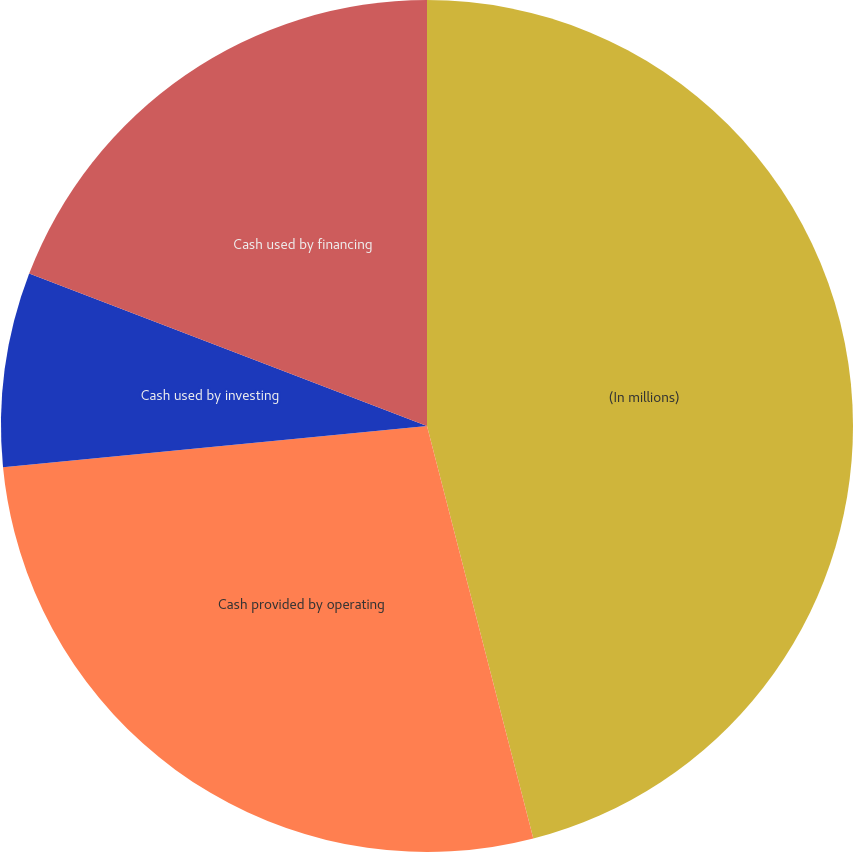Convert chart to OTSL. <chart><loc_0><loc_0><loc_500><loc_500><pie_chart><fcel>(In millions)<fcel>Cash provided by operating<fcel>Cash used by investing<fcel>Cash used by financing<nl><fcel>45.99%<fcel>27.47%<fcel>7.37%<fcel>19.18%<nl></chart> 